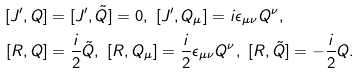Convert formula to latex. <formula><loc_0><loc_0><loc_500><loc_500>[ J ^ { \prime } , Q ] & = [ J ^ { \prime } , \tilde { Q } ] = 0 , \ [ J ^ { \prime } , Q _ { \mu } ] = i \epsilon _ { \mu \nu } Q ^ { \nu } , \\ [ R , Q ] & = \frac { i } { 2 } \tilde { Q } , \ [ R , Q _ { \mu } ] = \frac { i } { 2 } \epsilon _ { \mu \nu } Q ^ { \nu } , \ [ R , \tilde { Q } ] = - \frac { i } { 2 } Q .</formula> 